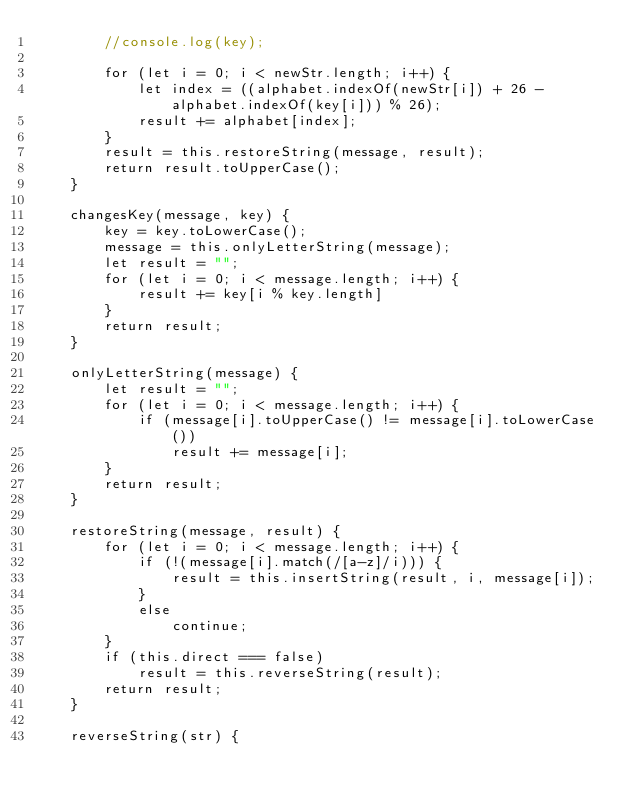Convert code to text. <code><loc_0><loc_0><loc_500><loc_500><_JavaScript_>        //console.log(key);

        for (let i = 0; i < newStr.length; i++) {
            let index = ((alphabet.indexOf(newStr[i]) + 26 - alphabet.indexOf(key[i])) % 26);
            result += alphabet[index];
        }
        result = this.restoreString(message, result);
        return result.toUpperCase();
    }

    changesKey(message, key) {
        key = key.toLowerCase();
        message = this.onlyLetterString(message);
        let result = "";
        for (let i = 0; i < message.length; i++) {
            result += key[i % key.length]
        }
        return result;
    }

    onlyLetterString(message) {
        let result = "";
        for (let i = 0; i < message.length; i++) {
            if (message[i].toUpperCase() != message[i].toLowerCase())
                result += message[i];
        }
        return result;
    }

    restoreString(message, result) {
        for (let i = 0; i < message.length; i++) {
            if (!(message[i].match(/[a-z]/i))) {
                result = this.insertString(result, i, message[i]);
            }
            else
                continue;
        }
        if (this.direct === false)
            result = this.reverseString(result);
        return result;
    }

    reverseString(str) {</code> 